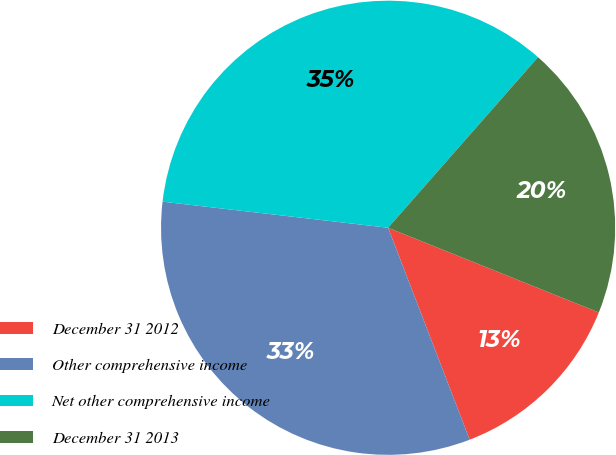Convert chart. <chart><loc_0><loc_0><loc_500><loc_500><pie_chart><fcel>December 31 2012<fcel>Other comprehensive income<fcel>Net other comprehensive income<fcel>December 31 2013<nl><fcel>13.07%<fcel>32.68%<fcel>34.64%<fcel>19.61%<nl></chart> 